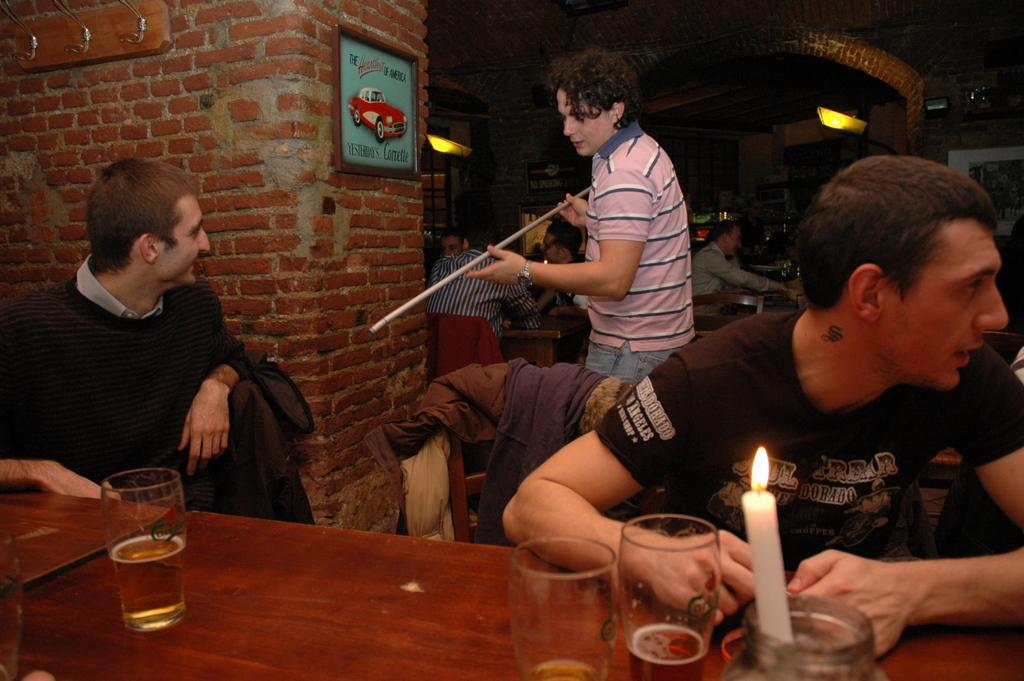How many people are in the image? There are persons in the image, but the exact number is not specified. What is on the table in the image? There are glasses and a candle on the table in the image. What is hanging on the wall in the image? There is a frame on the wall in the image. What type of lighting is present in the image? There are lights in the image. What story is being told by the part of the spring that is visible in the image? There is no mention of a spring or any story in the image; it features persons, a table, glasses, a candle, a wall, a frame, and lights. 